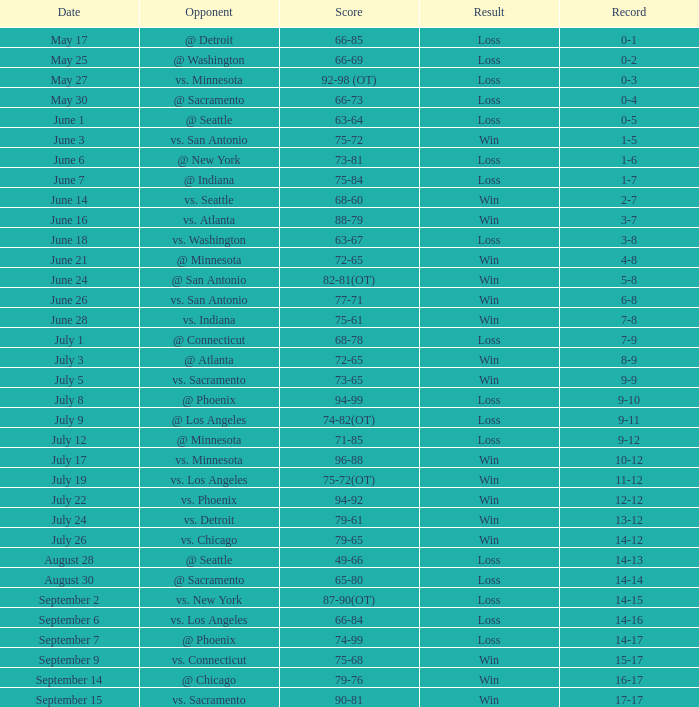What was the tally of the contest with a record of 0-1? 66-85. 